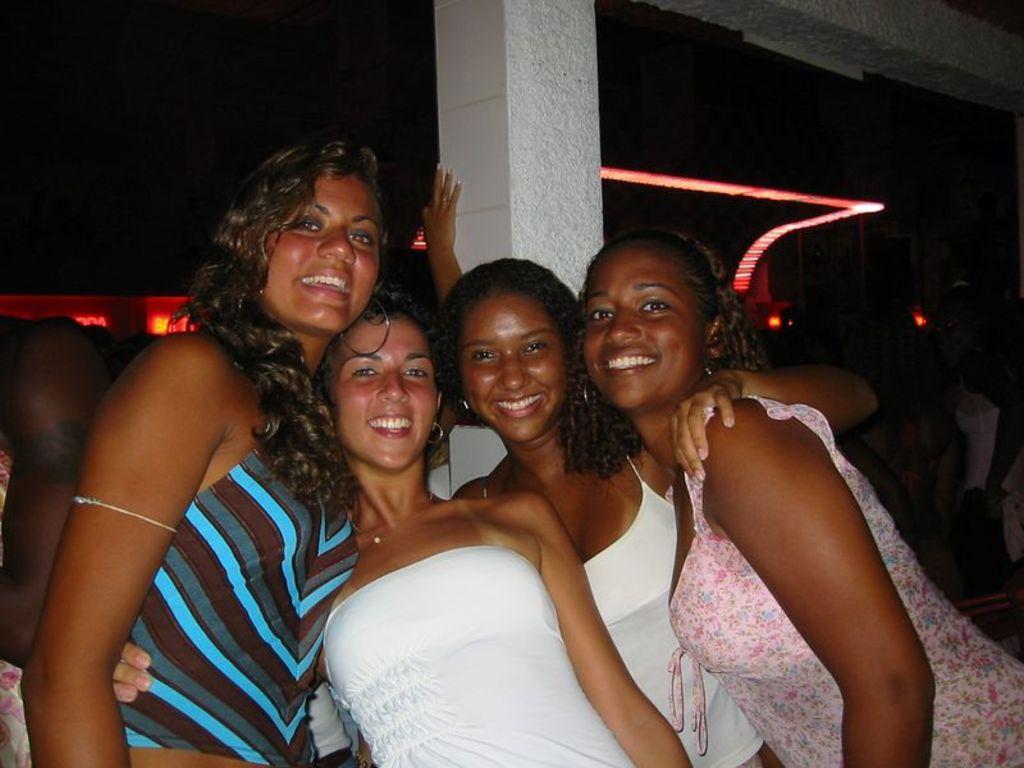How would you summarize this image in a sentence or two? In the image there are a group of women posing for the photo, behind them there is a pillar and in the background there are some other people and there is a red color light in the background. 